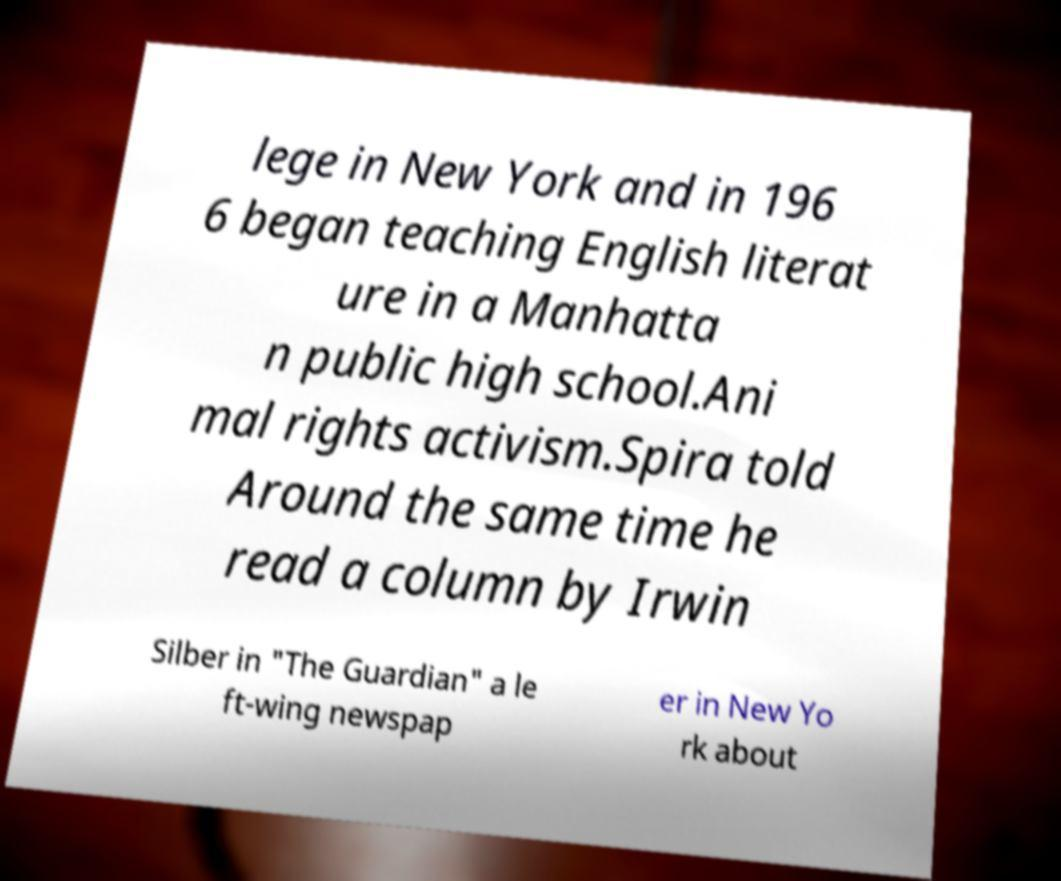Please identify and transcribe the text found in this image. lege in New York and in 196 6 began teaching English literat ure in a Manhatta n public high school.Ani mal rights activism.Spira told Around the same time he read a column by Irwin Silber in "The Guardian" a le ft-wing newspap er in New Yo rk about 